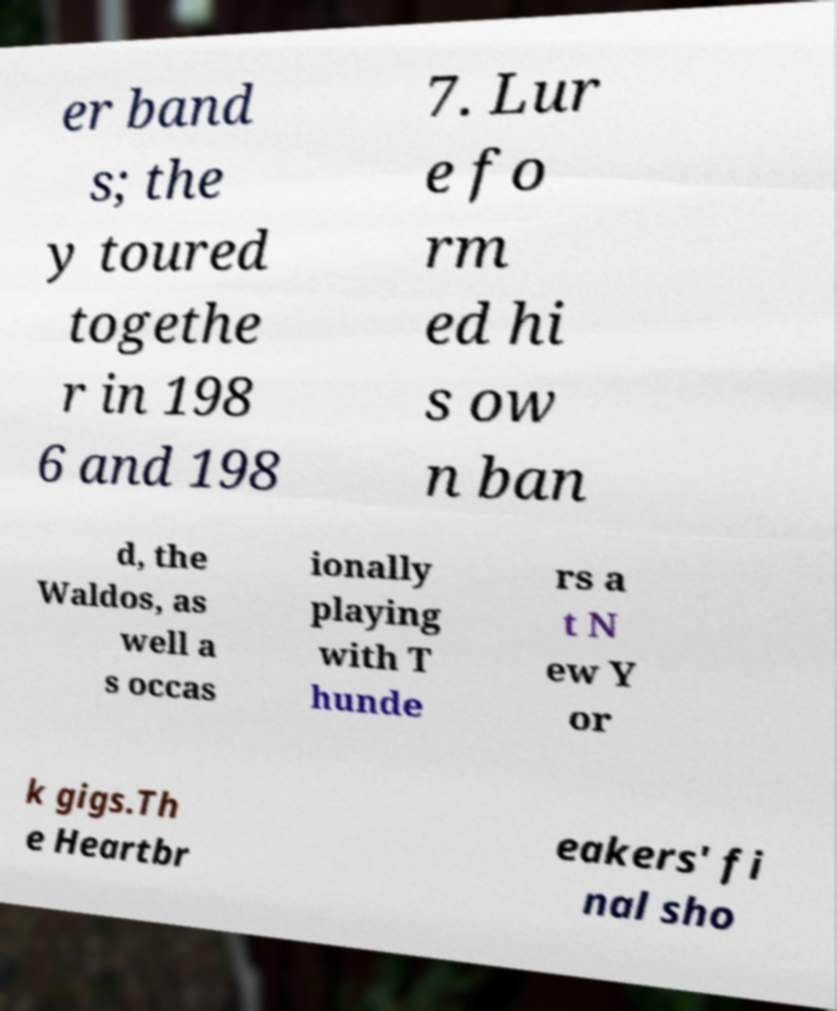Please read and relay the text visible in this image. What does it say? er band s; the y toured togethe r in 198 6 and 198 7. Lur e fo rm ed hi s ow n ban d, the Waldos, as well a s occas ionally playing with T hunde rs a t N ew Y or k gigs.Th e Heartbr eakers' fi nal sho 